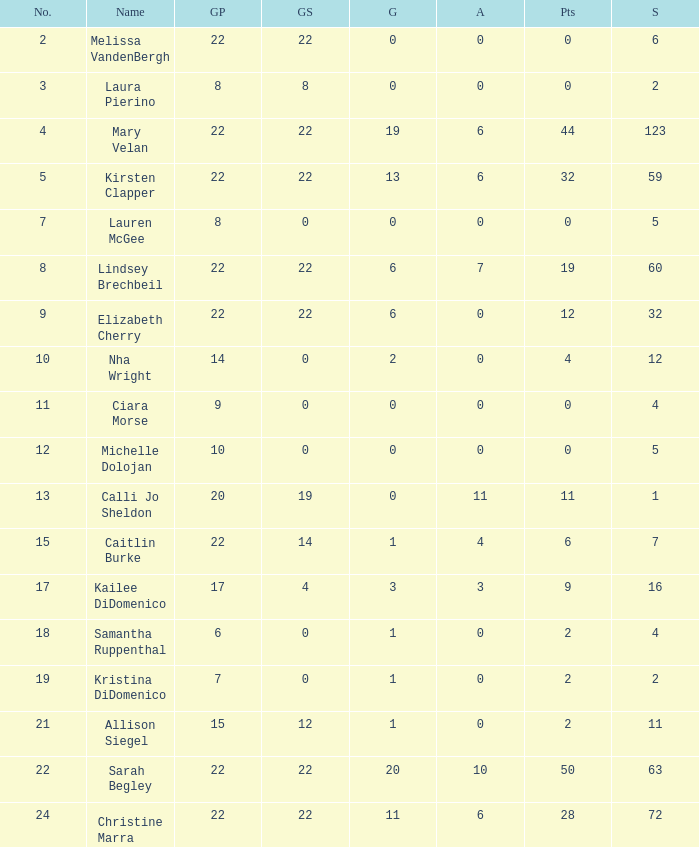How many names are listed for the player with 50 points? 1.0. 